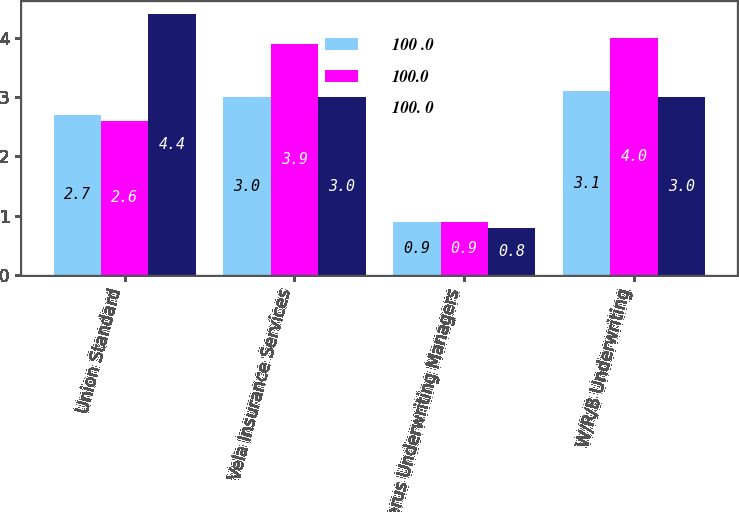Convert chart to OTSL. <chart><loc_0><loc_0><loc_500><loc_500><stacked_bar_chart><ecel><fcel>Union Standard<fcel>Vela Insurance Services<fcel>Verus Underwriting Managers<fcel>W/R/B Underwriting<nl><fcel>100 .0<fcel>2.7<fcel>3<fcel>0.9<fcel>3.1<nl><fcel>100.0<fcel>2.6<fcel>3.9<fcel>0.9<fcel>4<nl><fcel>100. 0<fcel>4.4<fcel>3<fcel>0.8<fcel>3<nl></chart> 